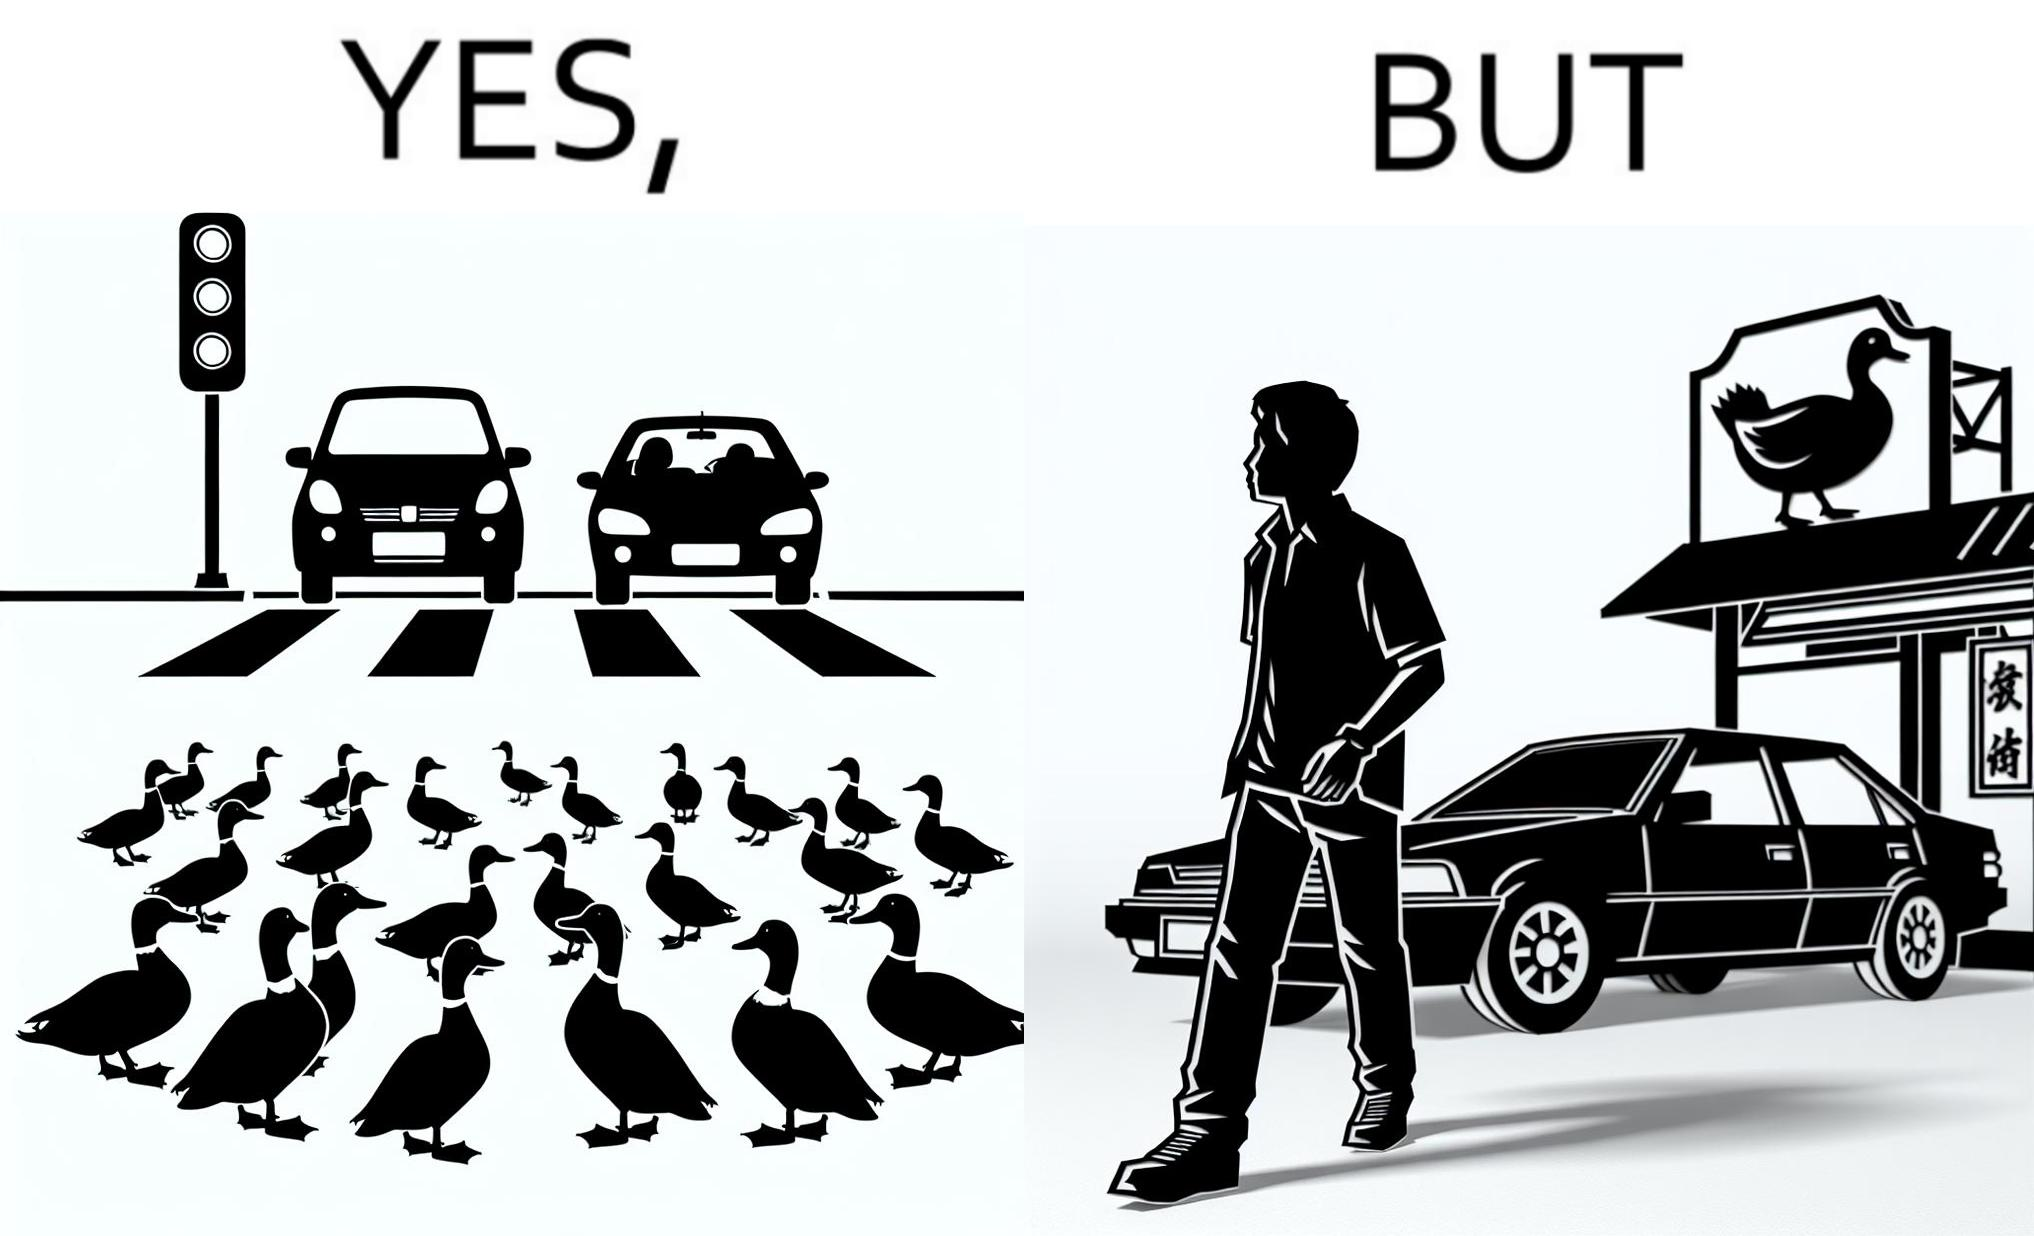Provide a description of this image. The images are ironic since they show how a man supposedly cares for ducks since he stops his vehicle to give way to queue of ducks allowing them to safely cross a road but on the other hand he goes to a peking duck shop to buy and eat similar ducks after having them killed 